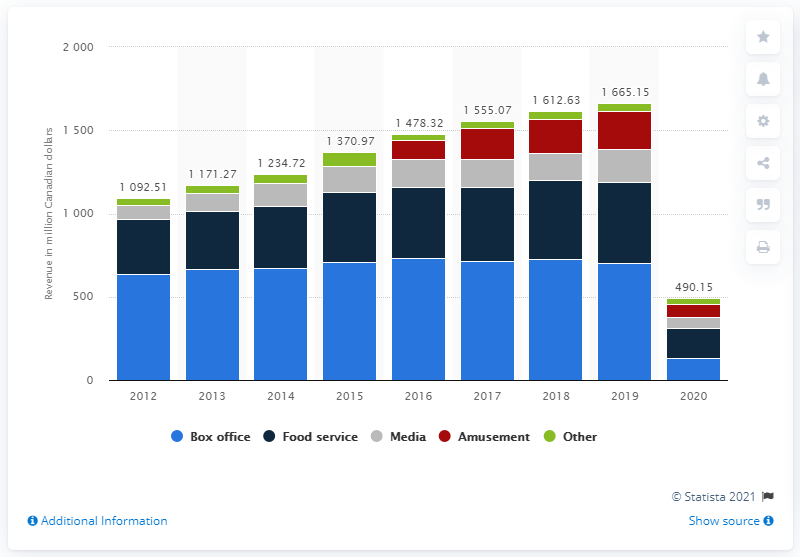Specify some key components in this picture. In 2020, Cineplex generated CAD 132.71 million in revenue. 